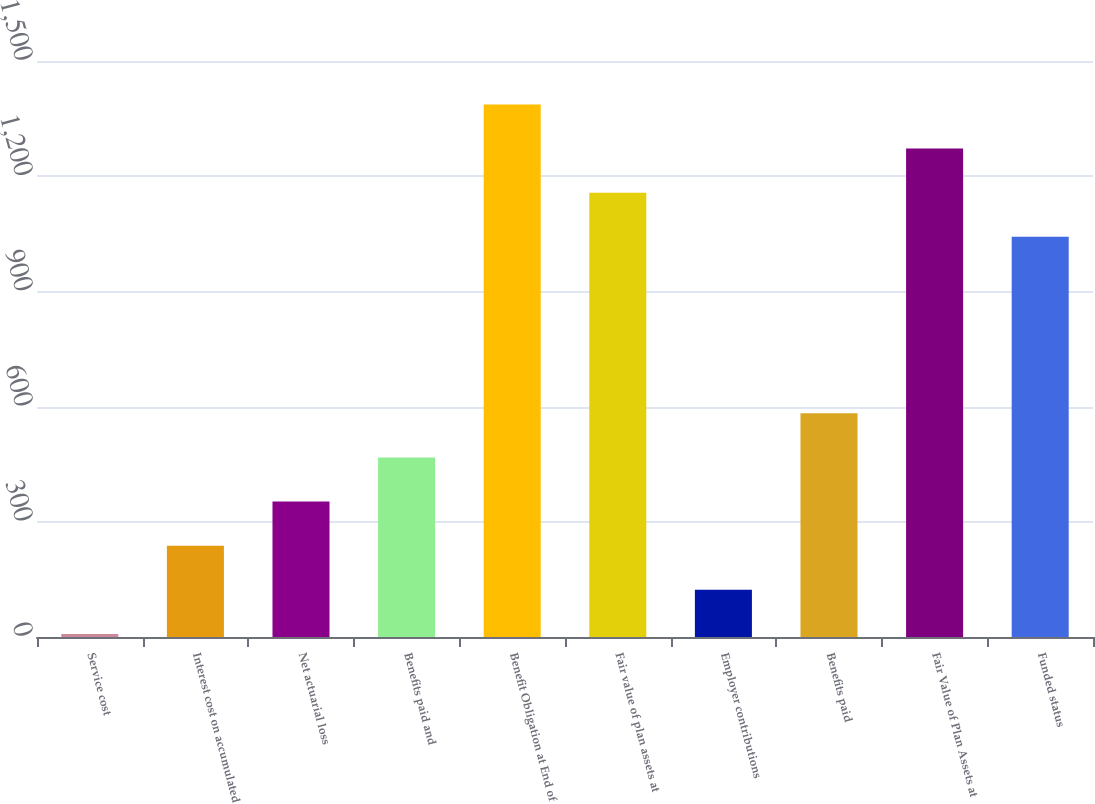<chart> <loc_0><loc_0><loc_500><loc_500><bar_chart><fcel>Service cost<fcel>Interest cost on accumulated<fcel>Net actuarial loss<fcel>Benefits paid and<fcel>Benefit Obligation at End of<fcel>Fair value of plan assets at<fcel>Employer contributions<fcel>Benefits paid<fcel>Fair Value of Plan Assets at<fcel>Funded status<nl><fcel>8<fcel>237.8<fcel>352.7<fcel>467.6<fcel>1386.8<fcel>1157<fcel>122.9<fcel>582.5<fcel>1271.9<fcel>1042.1<nl></chart> 